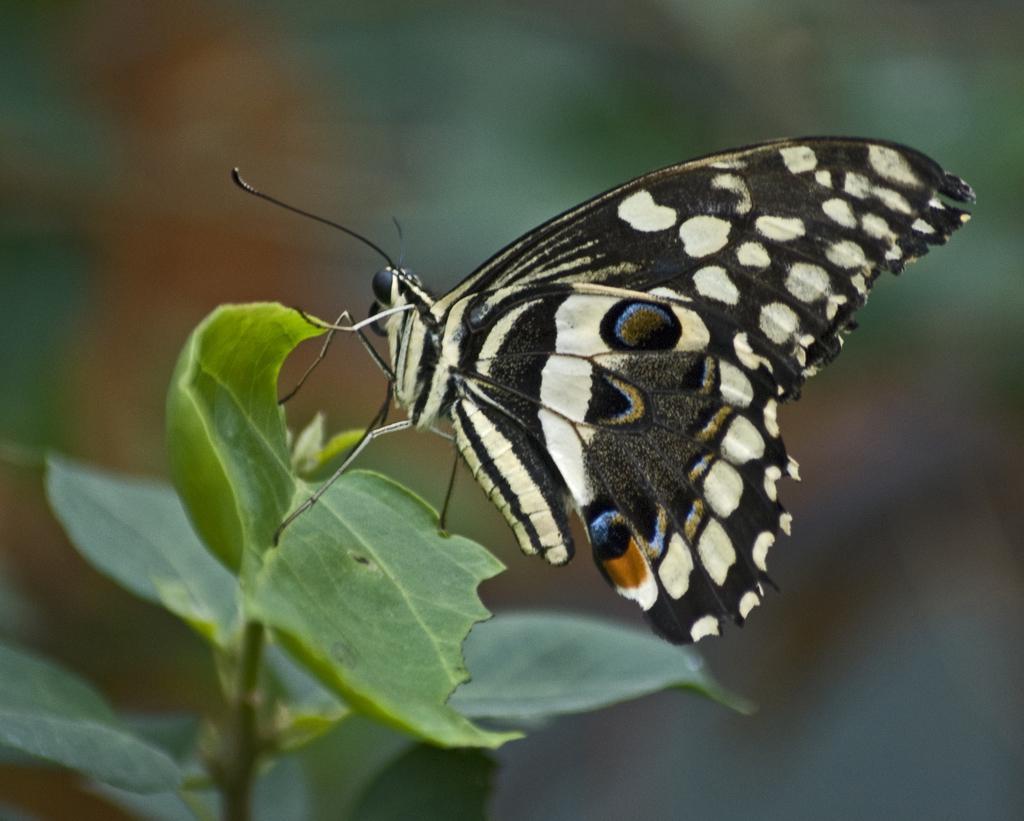Can you describe this image briefly? In the picture I can see a butterfly and green leaves. 